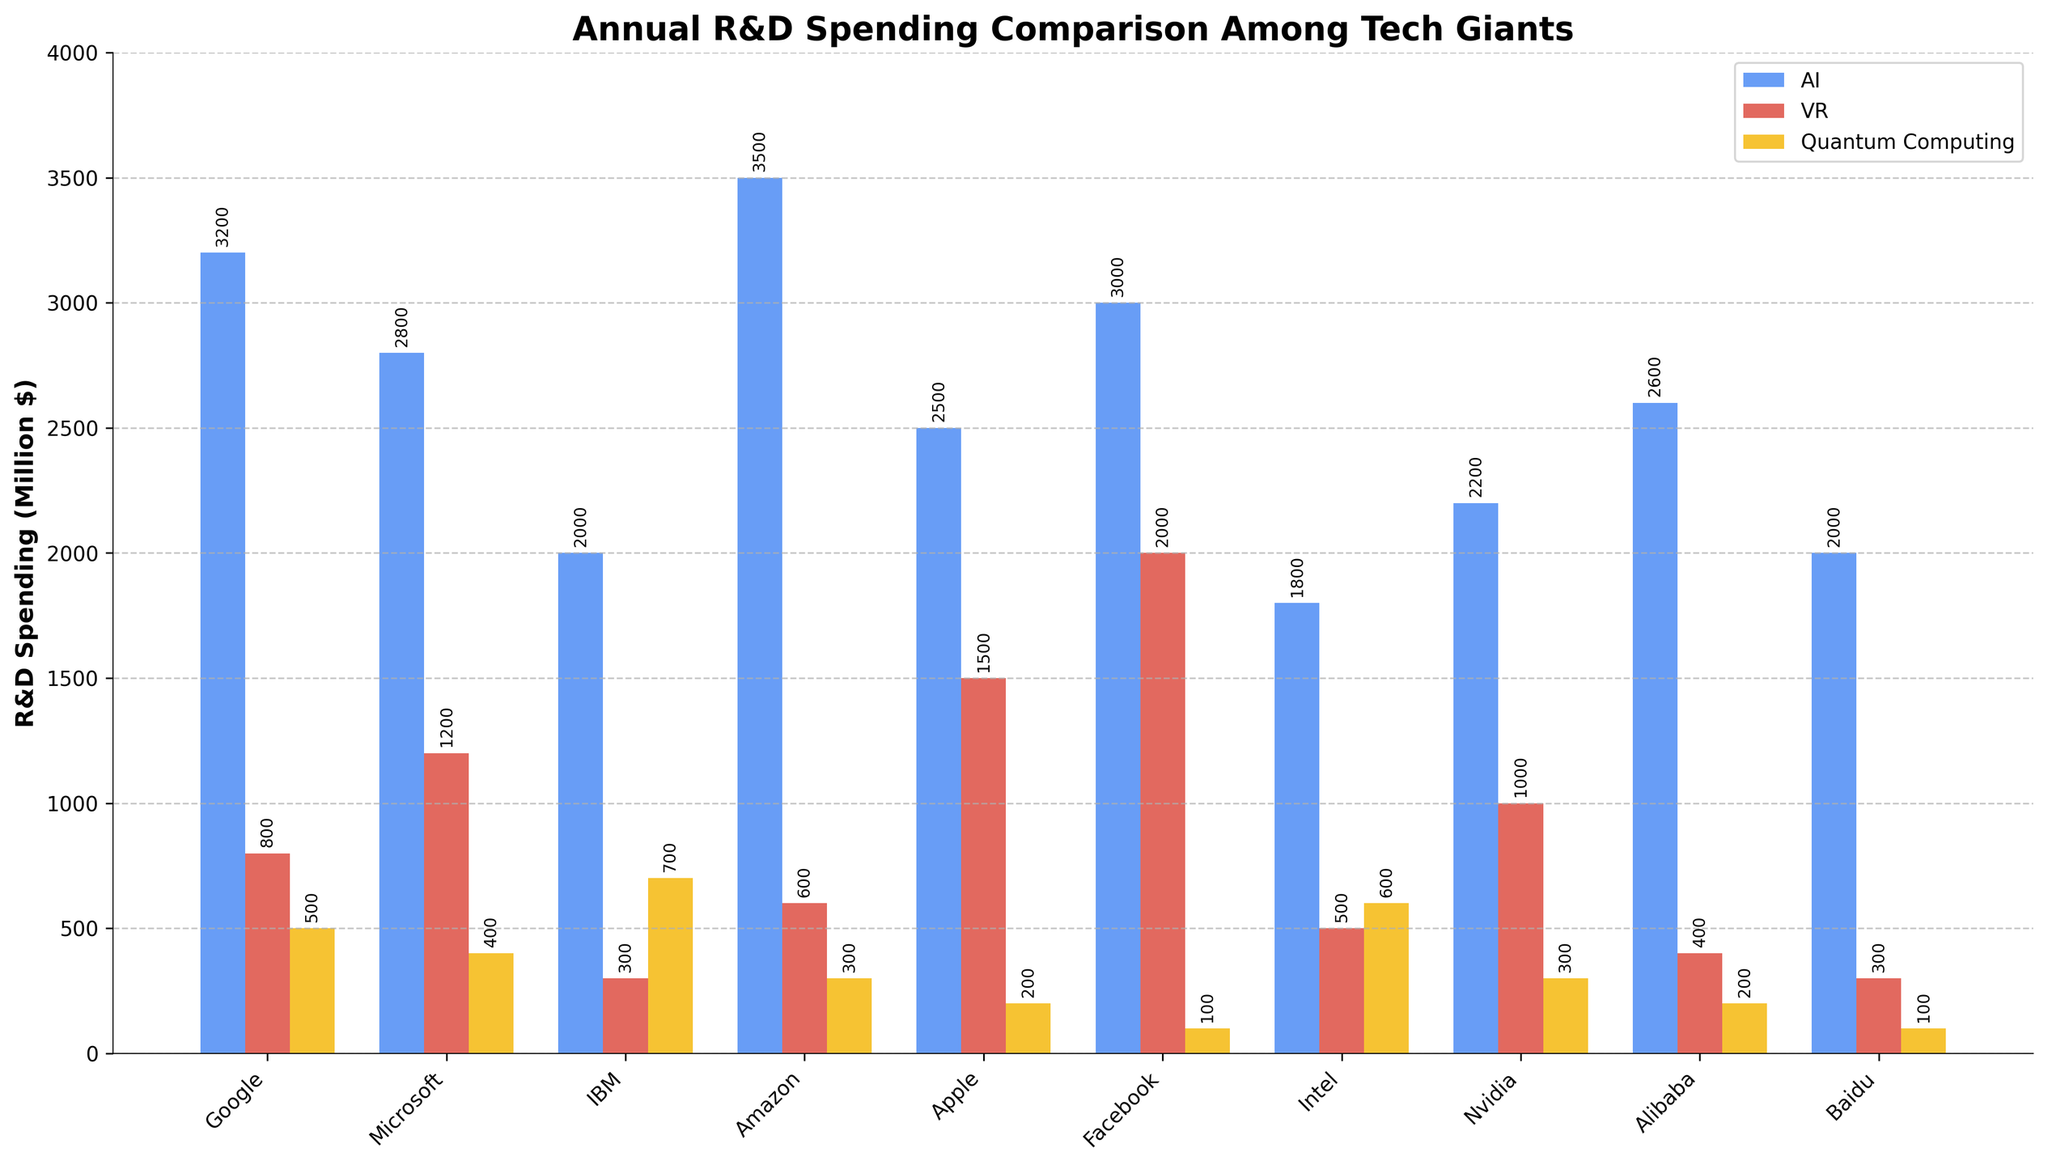Which company has the highest VR R&D spending? By looking at the height of the red bars in the chart, we can see that Facebook has the highest bar for VR.
Answer: Facebook Which two companies spend the most on AI R&D? By observing the heights of the blue bars, we identify that Amazon and Google have the tallest bars for AI spending.
Answer: Amazon and Google How much more does Apple spend on VR compared to quantum computing? Apple's VR spending is 1500 million $, and its quantum computing spending is 200 million $. The difference is 1500 - 200 = 1300 million $.
Answer: 1300 million $ Which company spends the least on quantum computing? By observing the heights of the yellow bars, Baidu and Facebook have the smallest bars for quantum computing, indicating the least spending.
Answer: Baidu and Facebook What is the total R&D spending on AI by Google and Amazon combined? Google spends 3200 million $ on AI, and Amazon spends 3500 million $. Adding these two amounts, we get 3200 + 3500 = 6700 million $.
Answer: 6700 million $ What is the average R&D spending on quantum computing by IBM and Intel? IBM’s spending on quantum computing is 700 million $, and Intel’s is 600 million $. The average spending is (700 + 600) / 2 = 650 million $.
Answer: 650 million $ Which sector does Nvidia invest in the least and by how much? Comparing the heights of Nvidia’s bars, it invests the least in quantum computing (300 million $). This is less than its AI (2200 million $) and VR (1000 million $) spending.
Answer: Quantum computing, 300 million $ What is the difference between Microsoft's AI and VR R&D spending? Microsoft spends 2800 million $ on AI and 1200 million $ on VR. The difference is 2800 - 1200 = 1600 million $.
Answer: 1600 million $ Among the companies shown, which has the highest total combined R&D spending in all the categories? By adding the AI, VR, and quantum computing spending for each company, we see that Amazon has the largest total combined spending: 3500 + 600 + 300 = 4400 million $.
Answer: Amazon 